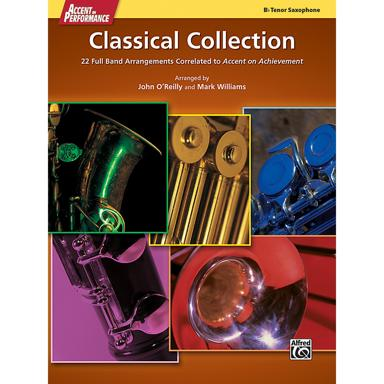Why might a classical collection specifically for the tenor saxophone be important for players? A classical collection tailored for the tenor saxophone is significant because it caters to the specific range, sound, and technique requirements of the instrument. This enables players to fully explore and develop their abilities within the classical genre, often expanding their repertoire and enhancing their performance skills. 